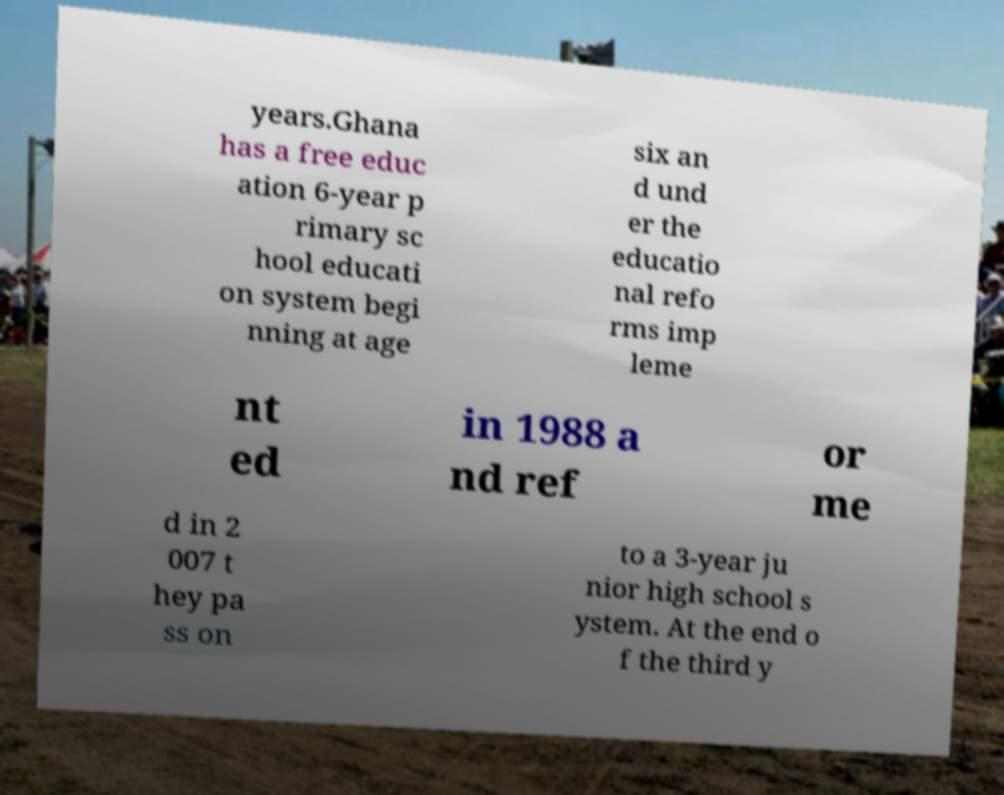Could you assist in decoding the text presented in this image and type it out clearly? years.Ghana has a free educ ation 6-year p rimary sc hool educati on system begi nning at age six an d und er the educatio nal refo rms imp leme nt ed in 1988 a nd ref or me d in 2 007 t hey pa ss on to a 3-year ju nior high school s ystem. At the end o f the third y 